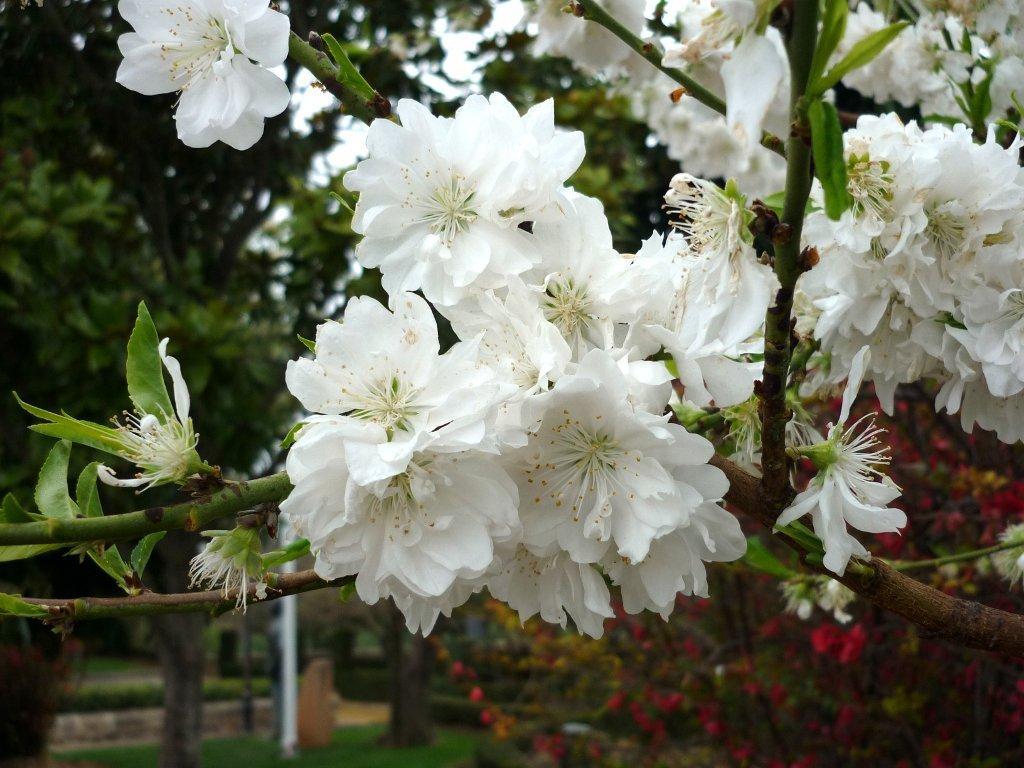In one or two sentences, can you explain what this image depicts? Here we can see a plant with flowers. In the background there are trees, pole, plants with flowers and sky. 